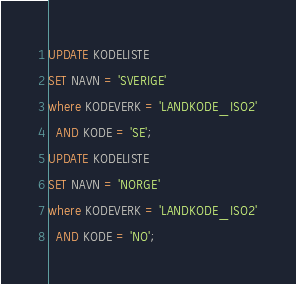<code> <loc_0><loc_0><loc_500><loc_500><_SQL_>UPDATE KODELISTE
SET NAVN = 'SVERIGE'
where KODEVERK = 'LANDKODE_ISO2'
  AND KODE = 'SE';
UPDATE KODELISTE
SET NAVN = 'NORGE'
where KODEVERK = 'LANDKODE_ISO2'
  AND KODE = 'NO';</code> 